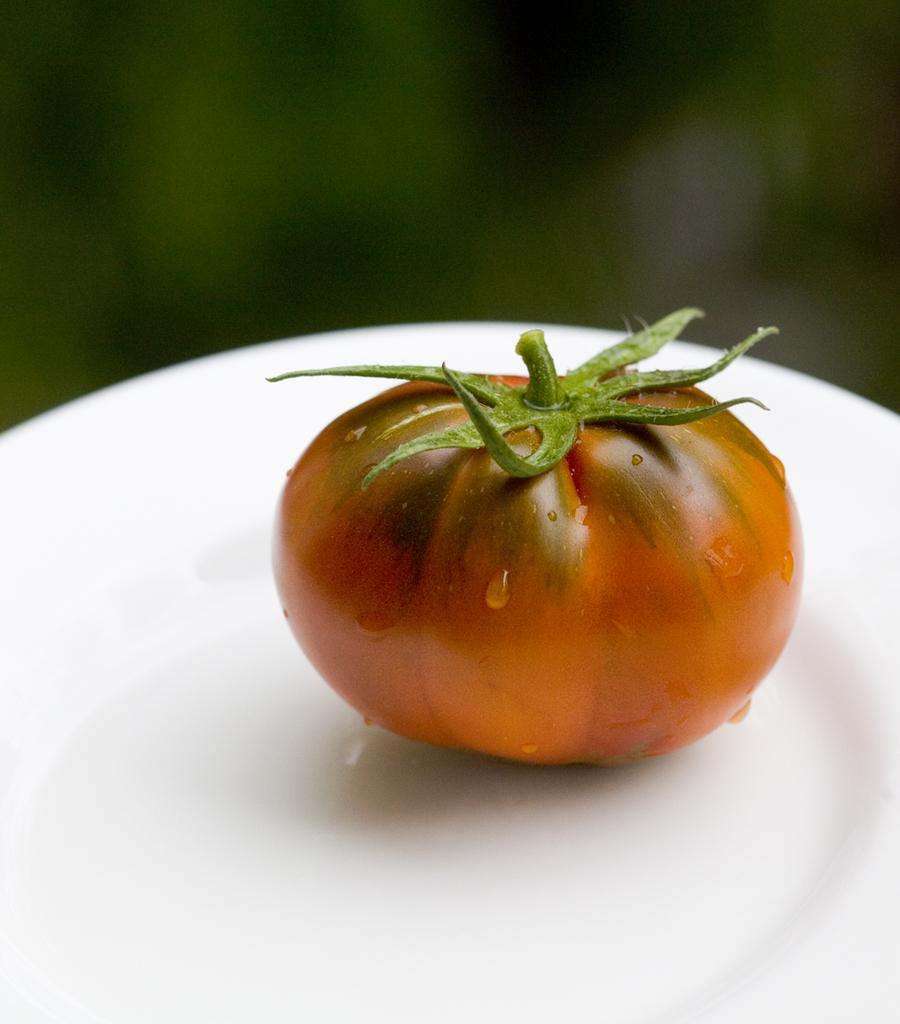What is the main subject of the image? The main subject of the image is a tomato. Where is the tomato located in the image? The tomato is on a white surface, likely a plate. Can you describe the background of the image? The background of the image is blurred. What rhythm is the tomato dancing to in the image? The tomato is not dancing in the image, and there is no rhythm present. 